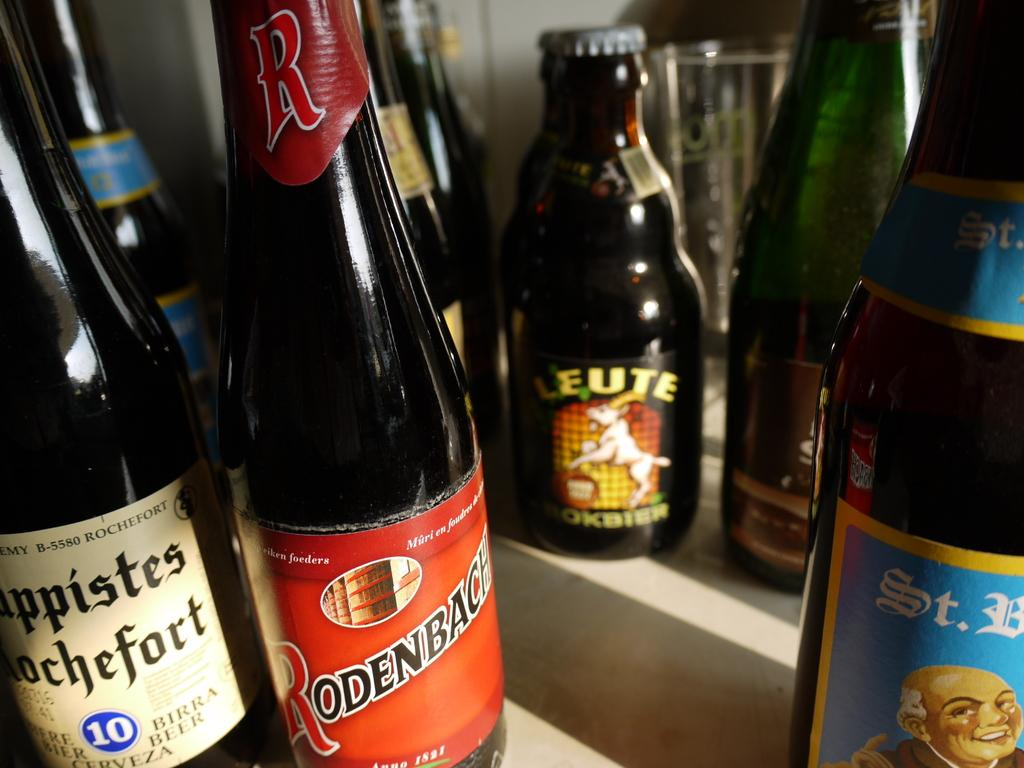<image>
Relay a brief, clear account of the picture shown. A bottle with a red label that says Rodenbach. 